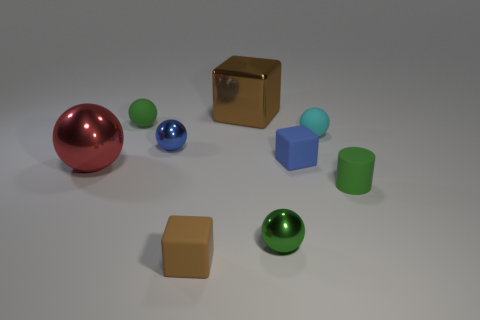Subtract all blue blocks. How many blocks are left? 2 Subtract all red shiny spheres. How many spheres are left? 4 Subtract all cylinders. How many objects are left? 8 Subtract 2 blocks. How many blocks are left? 1 Add 7 brown things. How many brown things exist? 9 Add 1 green rubber objects. How many objects exist? 10 Subtract 0 red cylinders. How many objects are left? 9 Subtract all cyan balls. Subtract all gray blocks. How many balls are left? 4 Subtract all gray balls. How many gray blocks are left? 0 Subtract all small yellow metallic things. Subtract all rubber cylinders. How many objects are left? 8 